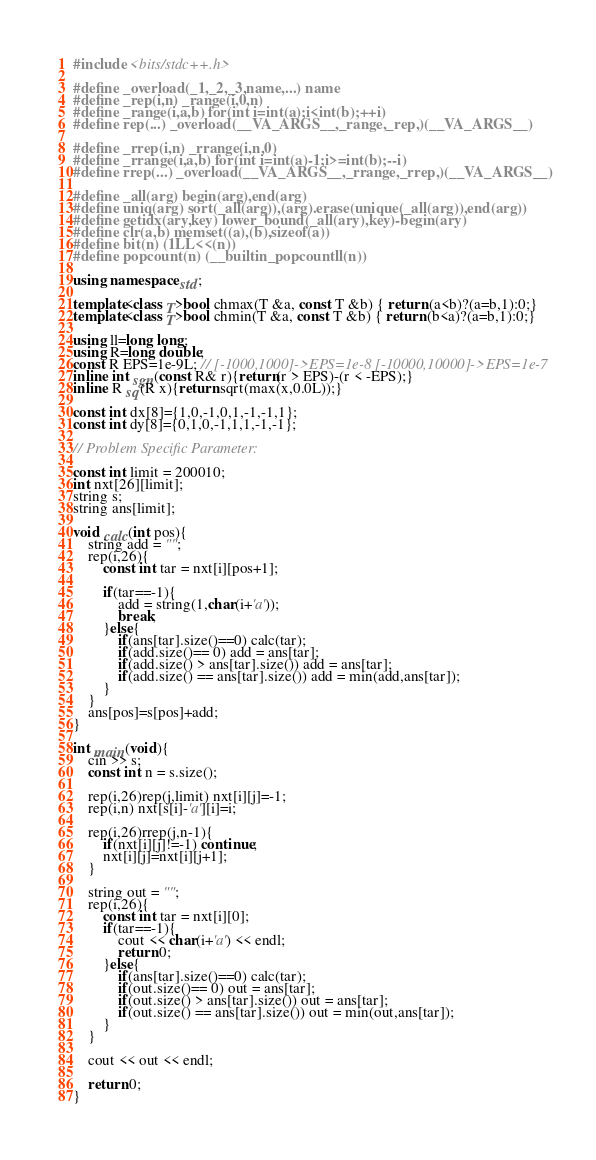<code> <loc_0><loc_0><loc_500><loc_500><_C++_>#include <bits/stdc++.h>

#define _overload(_1,_2,_3,name,...) name
#define _rep(i,n) _range(i,0,n)
#define _range(i,a,b) for(int i=int(a);i<int(b);++i)
#define rep(...) _overload(__VA_ARGS__,_range,_rep,)(__VA_ARGS__)

#define _rrep(i,n) _rrange(i,n,0)
#define _rrange(i,a,b) for(int i=int(a)-1;i>=int(b);--i)
#define rrep(...) _overload(__VA_ARGS__,_rrange,_rrep,)(__VA_ARGS__)

#define _all(arg) begin(arg),end(arg)
#define uniq(arg) sort(_all(arg)),(arg).erase(unique(_all(arg)),end(arg))
#define getidx(ary,key) lower_bound(_all(ary),key)-begin(ary)
#define clr(a,b) memset((a),(b),sizeof(a))
#define bit(n) (1LL<<(n))
#define popcount(n) (__builtin_popcountll(n))

using namespace std;

template<class T>bool chmax(T &a, const T &b) { return (a<b)?(a=b,1):0;}
template<class T>bool chmin(T &a, const T &b) { return (b<a)?(a=b,1):0;}

using ll=long long;
using R=long double;
const R EPS=1e-9L; // [-1000,1000]->EPS=1e-8 [-10000,10000]->EPS=1e-7
inline int sgn(const R& r){return(r > EPS)-(r < -EPS);}
inline R sq(R x){return sqrt(max(x,0.0L));}

const int dx[8]={1,0,-1,0,1,-1,-1,1};
const int dy[8]={0,1,0,-1,1,1,-1,-1};

// Problem Specific Parameter:

const int limit = 200010;
int nxt[26][limit];
string s;
string ans[limit];

void calc(int pos){
	string add = "";
	rep(i,26){
		const int tar = nxt[i][pos+1];
			
		if(tar==-1){
			add = string(1,char(i+'a'));
			break;
		}else{
			if(ans[tar].size()==0) calc(tar);
			if(add.size()== 0) add = ans[tar];
			if(add.size() > ans[tar].size()) add = ans[tar];
			if(add.size() == ans[tar].size()) add = min(add,ans[tar]);
		}
	}
	ans[pos]=s[pos]+add;	
}

int main(void){
	cin >> s;
	const int n = s.size();

	rep(i,26)rep(j,limit) nxt[i][j]=-1;
	rep(i,n) nxt[s[i]-'a'][i]=i;

	rep(i,26)rrep(j,n-1){
		if(nxt[i][j]!=-1) continue;
		nxt[i][j]=nxt[i][j+1];
	}

	string out = "";
	rep(i,26){
		const int tar = nxt[i][0];
		if(tar==-1){
			cout << char(i+'a') << endl;
			return 0;
		}else{
			if(ans[tar].size()==0) calc(tar);
			if(out.size()== 0) out = ans[tar];
			if(out.size() > ans[tar].size()) out = ans[tar];
			if(out.size() == ans[tar].size()) out = min(out,ans[tar]);
		}
	}

	cout << out << endl;
	
	return 0;
}</code> 